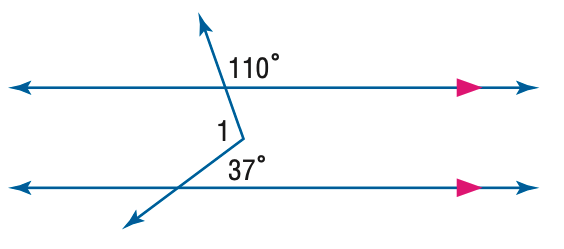Question: Find m \angle 1 in the figure.
Choices:
A. 37
B. 107
C. 110
D. 143
Answer with the letter. Answer: B 